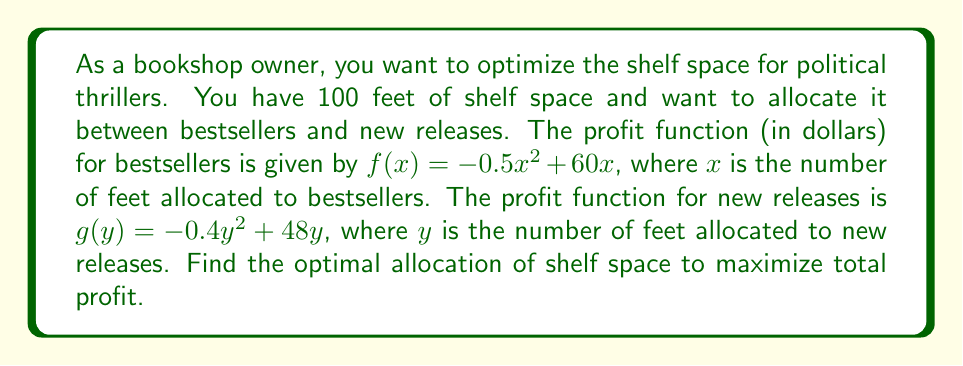Provide a solution to this math problem. 1) Let's approach this using polynomial optimization techniques:

2) We know that $x + y = 100$ (total shelf space), so $y = 100 - x$

3) The total profit function $P(x)$ is:
   $$P(x) = f(x) + g(100-x)$$
   $$P(x) = (-0.5x^2 + 60x) + (-0.4(100-x)^2 + 48(100-x))$$

4) Expand this:
   $$P(x) = -0.5x^2 + 60x - 0.4(10000 - 200x + x^2) + 4800 - 48x$$
   $$P(x) = -0.5x^2 + 60x - 4000 + 80x - 0.4x^2 + 4800 - 48x$$
   $$P(x) = -0.9x^2 + 92x + 800$$

5) To find the maximum, differentiate and set to zero:
   $$\frac{dP}{dx} = -1.8x + 92 = 0$$

6) Solve for x:
   $$x = \frac{92}{1.8} = 51.11$$

7) Round to the nearest whole number (as we can't allocate partial feet):
   $x = 51$ feet for bestsellers
   $y = 100 - 51 = 49$ feet for new releases

8) Check the second derivative to confirm it's a maximum:
   $$\frac{d^2P}{dx^2} = -1.8 < 0$$, confirming a maximum
Answer: 51 feet for bestsellers, 49 feet for new releases 